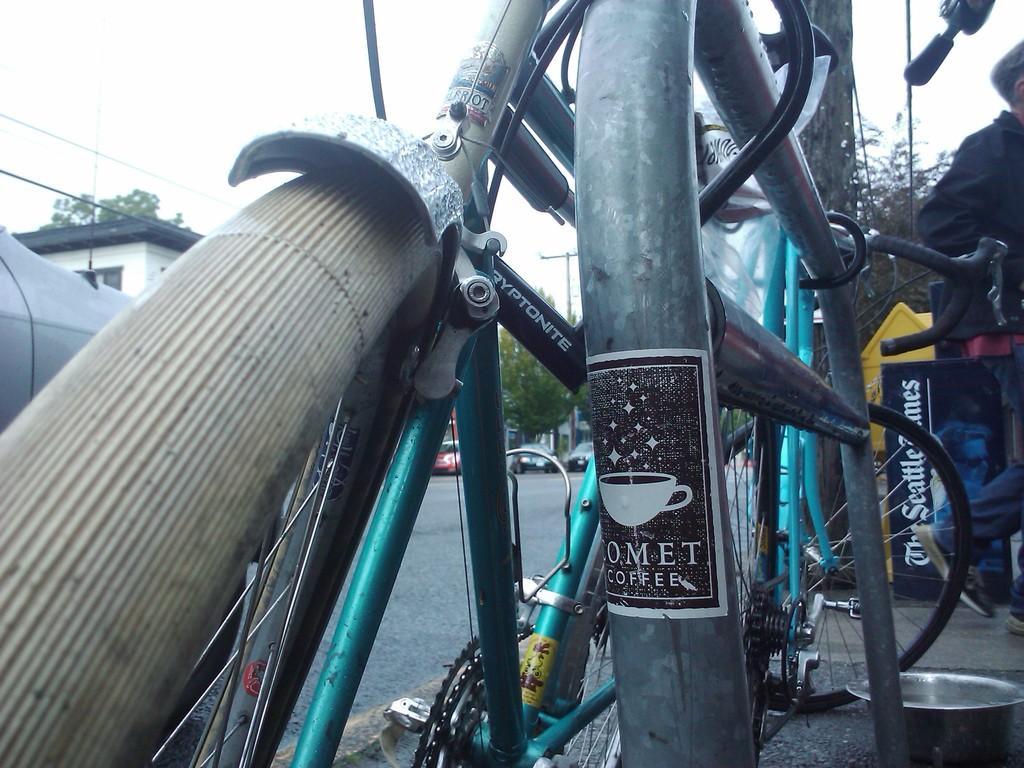In one or two sentences, can you explain what this image depicts? In this picture I can see bicycle. I can see trees and cars on road. I can see a person on the right hand side. I can see houses on left hand side. 